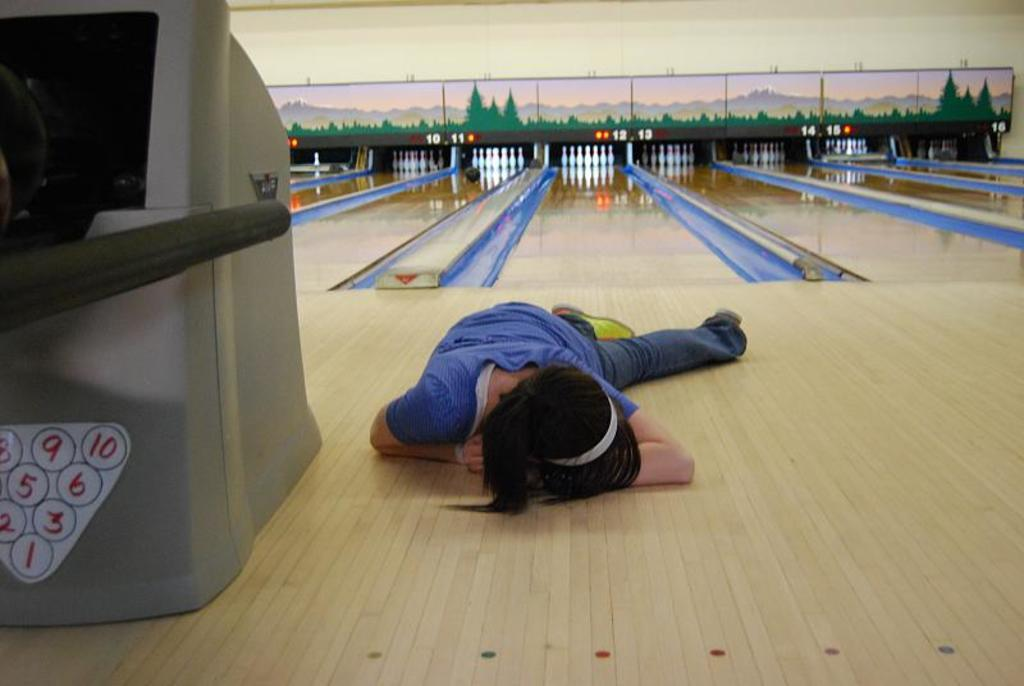What is the main subject in the foreground of the image? There is a person laying on the floor in the foreground of the image. What can be seen on the left side of the image? There is an object on the left side of the image. What type of location is depicted in the background of the image? There is a bowling game alley in the background of the image. What type of songs can be heard playing in the background of the image? There is no information about songs or music in the image, so it cannot be determined what, if any, songs might be heard. 